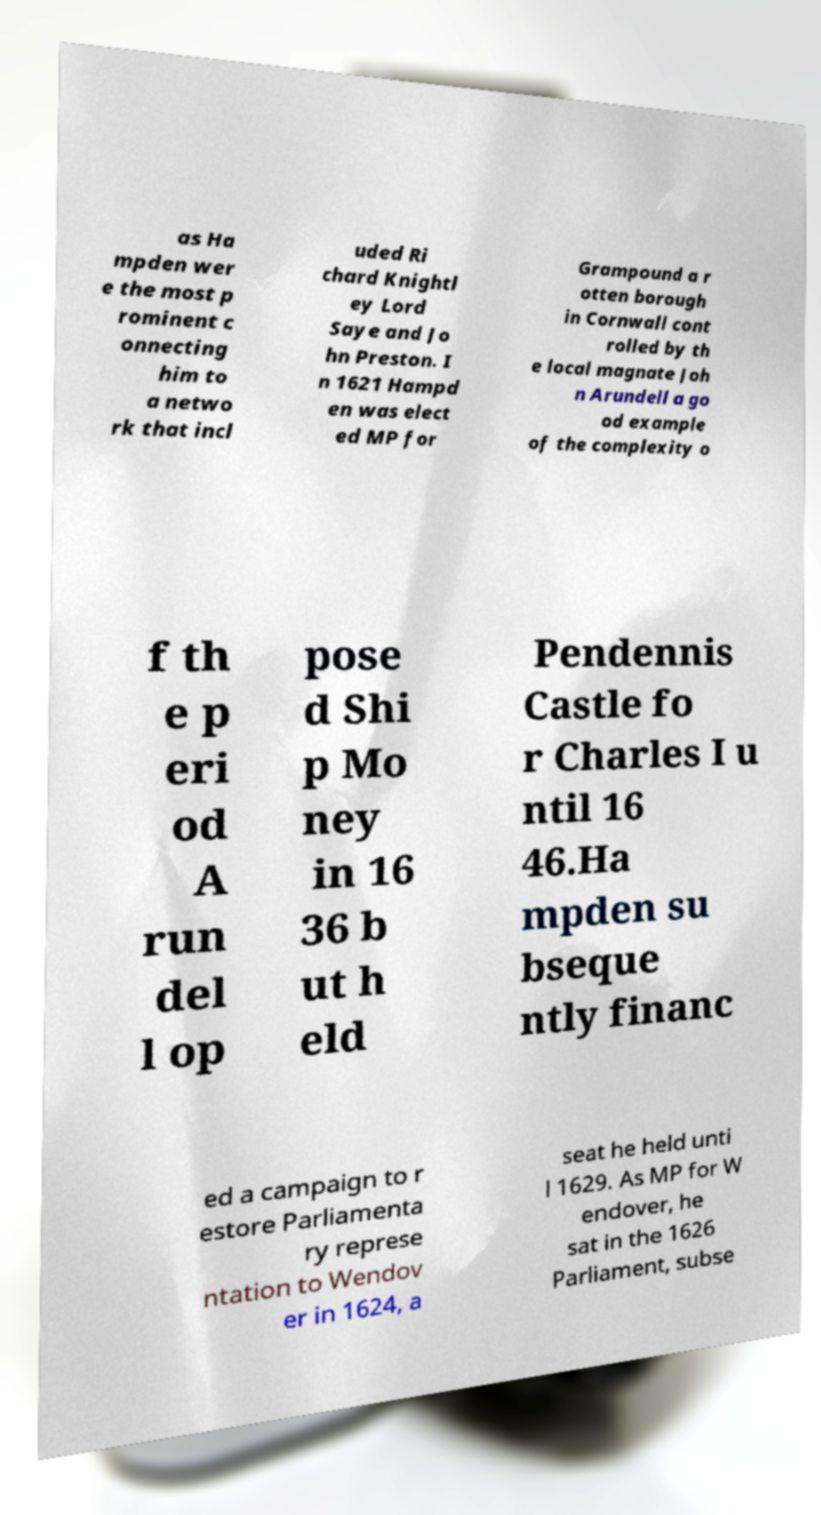Please identify and transcribe the text found in this image. as Ha mpden wer e the most p rominent c onnecting him to a netwo rk that incl uded Ri chard Knightl ey Lord Saye and Jo hn Preston. I n 1621 Hampd en was elect ed MP for Grampound a r otten borough in Cornwall cont rolled by th e local magnate Joh n Arundell a go od example of the complexity o f th e p eri od A run del l op pose d Shi p Mo ney in 16 36 b ut h eld Pendennis Castle fo r Charles I u ntil 16 46.Ha mpden su bseque ntly financ ed a campaign to r estore Parliamenta ry represe ntation to Wendov er in 1624, a seat he held unti l 1629. As MP for W endover, he sat in the 1626 Parliament, subse 